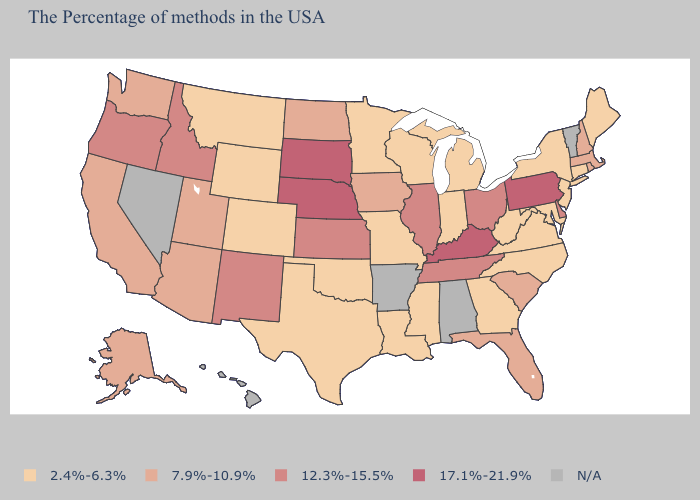What is the value of Nebraska?
Answer briefly. 17.1%-21.9%. Among the states that border Oregon , does California have the highest value?
Keep it brief. No. Name the states that have a value in the range 2.4%-6.3%?
Concise answer only. Maine, Connecticut, New York, New Jersey, Maryland, Virginia, North Carolina, West Virginia, Georgia, Michigan, Indiana, Wisconsin, Mississippi, Louisiana, Missouri, Minnesota, Oklahoma, Texas, Wyoming, Colorado, Montana. Is the legend a continuous bar?
Short answer required. No. Name the states that have a value in the range 2.4%-6.3%?
Concise answer only. Maine, Connecticut, New York, New Jersey, Maryland, Virginia, North Carolina, West Virginia, Georgia, Michigan, Indiana, Wisconsin, Mississippi, Louisiana, Missouri, Minnesota, Oklahoma, Texas, Wyoming, Colorado, Montana. Name the states that have a value in the range 7.9%-10.9%?
Be succinct. Massachusetts, Rhode Island, New Hampshire, South Carolina, Florida, Iowa, North Dakota, Utah, Arizona, California, Washington, Alaska. Is the legend a continuous bar?
Concise answer only. No. How many symbols are there in the legend?
Write a very short answer. 5. Name the states that have a value in the range 17.1%-21.9%?
Answer briefly. Pennsylvania, Kentucky, Nebraska, South Dakota. Name the states that have a value in the range 2.4%-6.3%?
Quick response, please. Maine, Connecticut, New York, New Jersey, Maryland, Virginia, North Carolina, West Virginia, Georgia, Michigan, Indiana, Wisconsin, Mississippi, Louisiana, Missouri, Minnesota, Oklahoma, Texas, Wyoming, Colorado, Montana. Name the states that have a value in the range 7.9%-10.9%?
Give a very brief answer. Massachusetts, Rhode Island, New Hampshire, South Carolina, Florida, Iowa, North Dakota, Utah, Arizona, California, Washington, Alaska. Among the states that border North Dakota , which have the highest value?
Be succinct. South Dakota. Among the states that border New Mexico , does Oklahoma have the lowest value?
Short answer required. Yes. What is the value of Idaho?
Give a very brief answer. 12.3%-15.5%. 